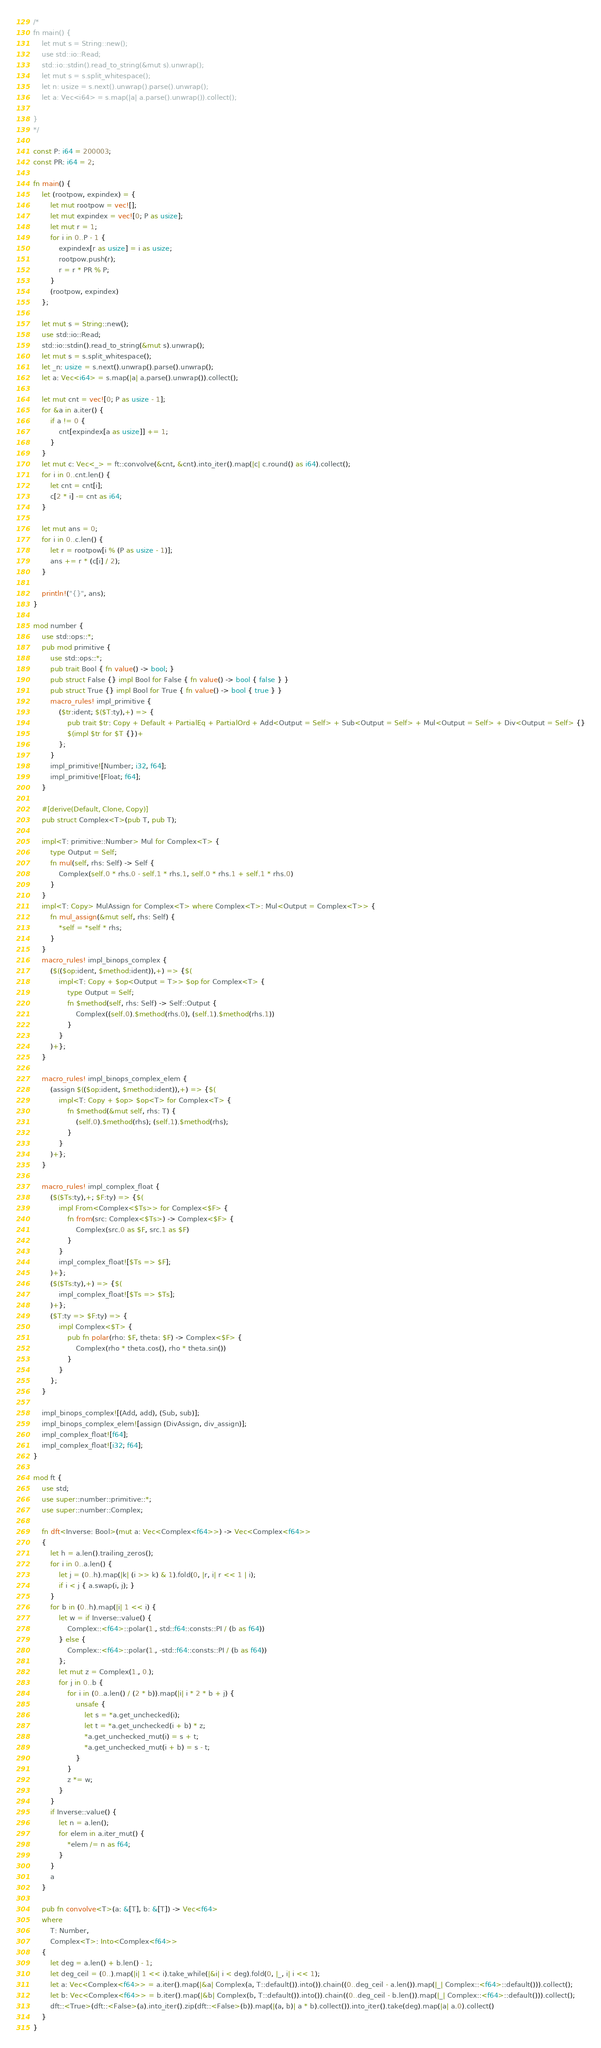<code> <loc_0><loc_0><loc_500><loc_500><_Rust_>/*
fn main() {
	let mut s = String::new();
	use std::io::Read;
	std::io::stdin().read_to_string(&mut s).unwrap();
	let mut s = s.split_whitespace();
	let n: usize = s.next().unwrap().parse().unwrap();
	let a: Vec<i64> = s.map(|a| a.parse().unwrap()).collect();

}
*/

const P: i64 = 200003;
const PR: i64 = 2;

fn main() {
	let (rootpow, expindex) = {
		let mut rootpow = vec![];
		let mut expindex = vec![0; P as usize];
		let mut r = 1;
		for i in 0..P - 1 {
			expindex[r as usize] = i as usize;
			rootpow.push(r);
			r = r * PR % P;
		}
		(rootpow, expindex)
	};

	let mut s = String::new();
	use std::io::Read;
	std::io::stdin().read_to_string(&mut s).unwrap();
	let mut s = s.split_whitespace();
	let _n: usize = s.next().unwrap().parse().unwrap();
	let a: Vec<i64> = s.map(|a| a.parse().unwrap()).collect();

	let mut cnt = vec![0; P as usize - 1];
	for &a in a.iter() {
		if a != 0 {
			cnt[expindex[a as usize]] += 1;
		}
	}
	let mut c: Vec<_> = ft::convolve(&cnt, &cnt).into_iter().map(|c| c.round() as i64).collect();
	for i in 0..cnt.len() {
		let cnt = cnt[i];
		c[2 * i] -= cnt as i64;
	}

	let mut ans = 0;
	for i in 0..c.len() {
		let r = rootpow[i % (P as usize - 1)];
		ans += r * (c[i] / 2);
	}

	println!("{}", ans);
}

mod number {
	use std::ops::*;
	pub mod primitive {
		use std::ops::*;
		pub trait Bool { fn value() -> bool; }
		pub struct False {} impl Bool for False { fn value() -> bool { false } }
		pub struct True {} impl Bool for True { fn value() -> bool { true } }
		macro_rules! impl_primitive {
			($tr:ident; $($T:ty),+) => {
				pub trait $tr: Copy + Default + PartialEq + PartialOrd + Add<Output = Self> + Sub<Output = Self> + Mul<Output = Self> + Div<Output = Self> {}
				$(impl $tr for $T {})+
			};
		}
		impl_primitive![Number; i32, f64];
		impl_primitive![Float; f64];
	}

	#[derive(Default, Clone, Copy)]
	pub struct Complex<T>(pub T, pub T);

	impl<T: primitive::Number> Mul for Complex<T> {
		type Output = Self;
		fn mul(self, rhs: Self) -> Self {
			Complex(self.0 * rhs.0 - self.1 * rhs.1, self.0 * rhs.1 + self.1 * rhs.0)
		}
	}
	impl<T: Copy> MulAssign for Complex<T> where Complex<T>: Mul<Output = Complex<T>> {
		fn mul_assign(&mut self, rhs: Self) {
			*self = *self * rhs;
		}
	}
	macro_rules! impl_binops_complex {
		($(($op:ident, $method:ident)),+) => {$(
			impl<T: Copy + $op<Output = T>> $op for Complex<T> {
				type Output = Self;
				fn $method(self, rhs: Self) -> Self::Output {
					Complex((self.0).$method(rhs.0), (self.1).$method(rhs.1))
				}
			}
		)+};
	}

	macro_rules! impl_binops_complex_elem {
		(assign $(($op:ident, $method:ident)),+) => {$(
			impl<T: Copy + $op> $op<T> for Complex<T> {
				fn $method(&mut self, rhs: T) {
					(self.0).$method(rhs); (self.1).$method(rhs);
				}
			}
		)+};
	}

	macro_rules! impl_complex_float {
		($($Ts:ty),+; $F:ty) => {$(
			impl From<Complex<$Ts>> for Complex<$F> {
				fn from(src: Complex<$Ts>) -> Complex<$F> {
					Complex(src.0 as $F, src.1 as $F)
				}
			}
			impl_complex_float![$Ts => $F];
		)+};
		($($Ts:ty),+) => {$(
			impl_complex_float![$Ts => $Ts];
		)+};
		($T:ty => $F:ty) => {
			impl Complex<$T> {
				pub fn polar(rho: $F, theta: $F) -> Complex<$F> {
					Complex(rho * theta.cos(), rho * theta.sin())
				}
			}
		};
	}

	impl_binops_complex![(Add, add), (Sub, sub)];
	impl_binops_complex_elem![assign (DivAssign, div_assign)];
	impl_complex_float![f64];
	impl_complex_float![i32; f64];
}

mod ft {
	use std;
	use super::number::primitive::*;
	use super::number::Complex;

	fn dft<Inverse: Bool>(mut a: Vec<Complex<f64>>) -> Vec<Complex<f64>>
	{
		let h = a.len().trailing_zeros();
		for i in 0..a.len() {
			let j = (0..h).map(|k| (i >> k) & 1).fold(0, |r, i| r << 1 | i);
			if i < j { a.swap(i, j); }
		}
		for b in (0..h).map(|i| 1 << i) {
			let w = if Inverse::value() {
				Complex::<f64>::polar(1., std::f64::consts::PI / (b as f64))
			} else {
				Complex::<f64>::polar(1., -std::f64::consts::PI / (b as f64))
			};
			let mut z = Complex(1., 0.);
			for j in 0..b {
				for i in (0..a.len() / (2 * b)).map(|i| i * 2 * b + j) {
					unsafe {
						let s = *a.get_unchecked(i);
						let t = *a.get_unchecked(i + b) * z;
						*a.get_unchecked_mut(i) = s + t;
						*a.get_unchecked_mut(i + b) = s - t;
					}
				}
				z *= w;
			}
		}
		if Inverse::value() {
			let n = a.len();
			for elem in a.iter_mut() {
				*elem /= n as f64;
			}
		}
		a
	}

	pub fn convolve<T>(a: &[T], b: &[T]) -> Vec<f64>
	where
		T: Number,
		Complex<T>: Into<Complex<f64>>
	{
		let deg = a.len() + b.len() - 1;
		let deg_ceil = (0..).map(|i| 1 << i).take_while(|&i| i < deg).fold(0, |_, i| i << 1);
		let a: Vec<Complex<f64>> = a.iter().map(|&a| Complex(a, T::default()).into()).chain((0..deg_ceil - a.len()).map(|_| Complex::<f64>::default())).collect();
		let b: Vec<Complex<f64>> = b.iter().map(|&b| Complex(b, T::default()).into()).chain((0..deg_ceil - b.len()).map(|_| Complex::<f64>::default())).collect();
		dft::<True>(dft::<False>(a).into_iter().zip(dft::<False>(b)).map(|(a, b)| a * b).collect()).into_iter().take(deg).map(|a| a.0).collect()
	}
}
</code> 